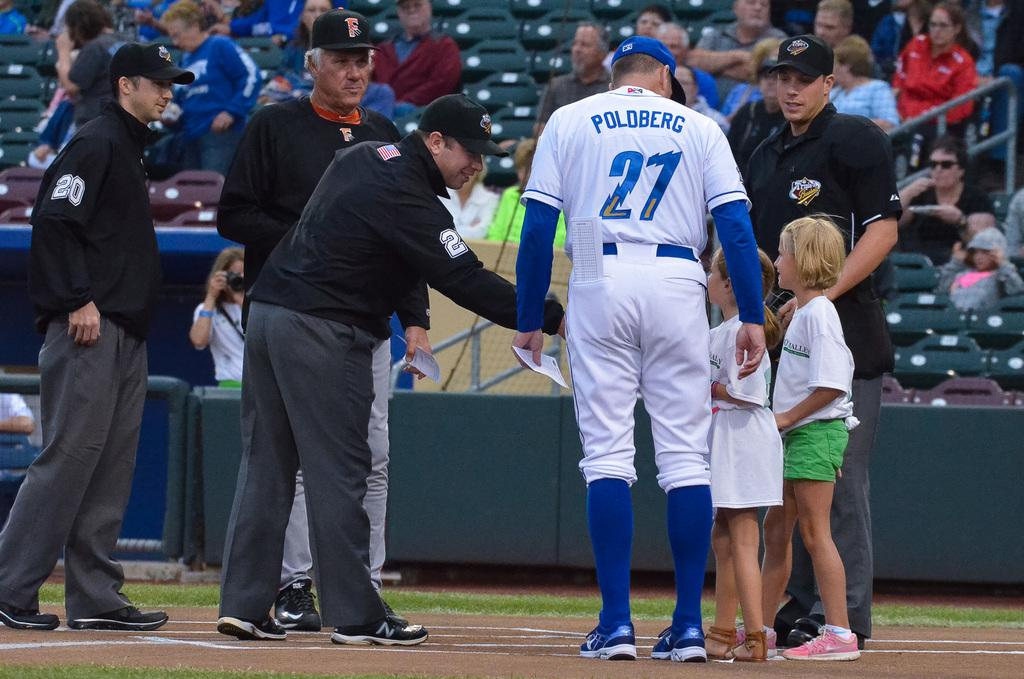Provide a one-sentence caption for the provided image. Baseball player wearing number 27 talking to some children. 